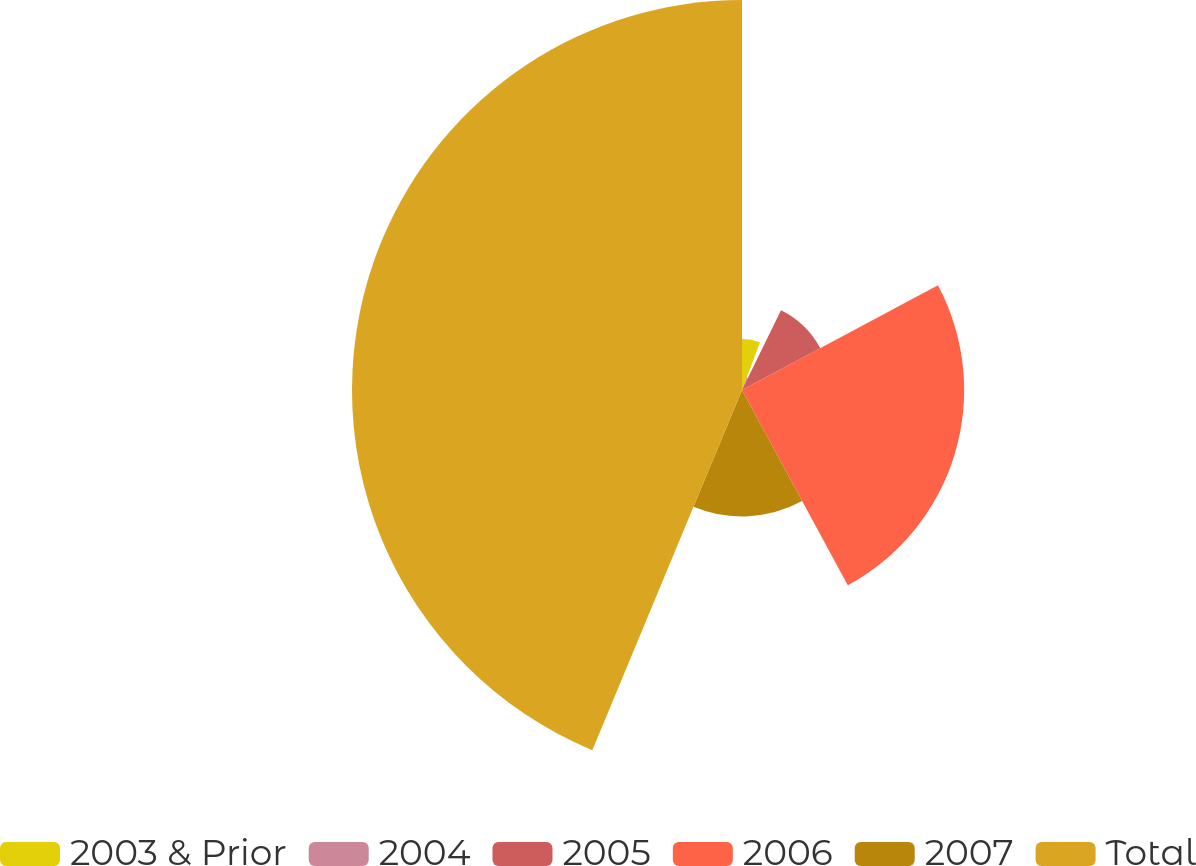Convert chart to OTSL. <chart><loc_0><loc_0><loc_500><loc_500><pie_chart><fcel>2003 & Prior<fcel>2004<fcel>2005<fcel>2006<fcel>2007<fcel>Total<nl><fcel>5.73%<fcel>1.51%<fcel>9.95%<fcel>24.91%<fcel>14.17%<fcel>43.73%<nl></chart> 